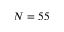<formula> <loc_0><loc_0><loc_500><loc_500>N = 5 5</formula> 